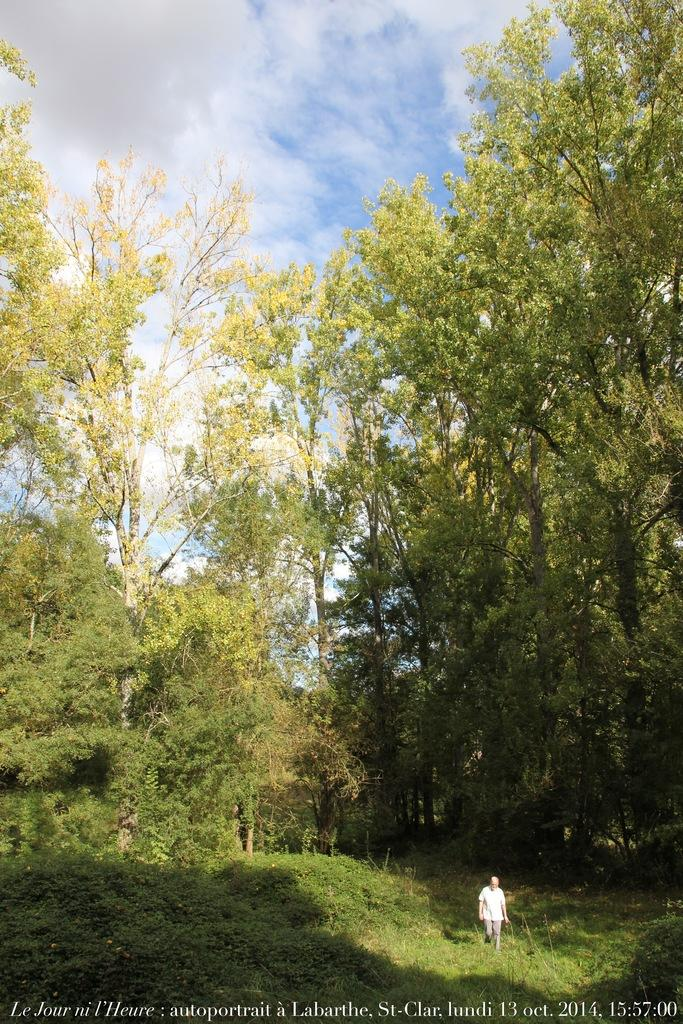What is the main subject in the image? There is a person standing in the image. What type of vegetation can be seen in the image? There are plants and trees in the image. What is visible in the background of the image? The sky is visible in the background of the image. Can you describe any additional features of the image? There is a watermark on the image. What type of glove is the person wearing in the image? There is no glove visible in the image; the person is not wearing any gloves. Can you see the roots of the plants in the image? The image does not show the roots of the plants; only the visible parts of the plants and trees are shown. 